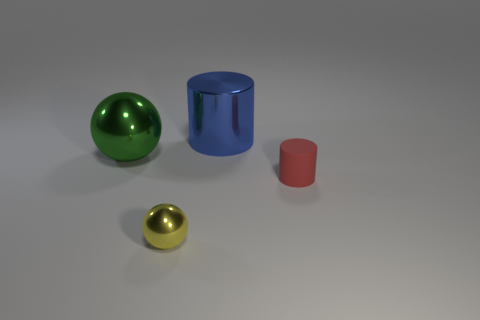There is a blue cylinder that is the same material as the yellow object; what is its size?
Offer a very short reply. Large. Is the size of the matte object the same as the yellow sphere to the left of the blue cylinder?
Provide a short and direct response. Yes. There is a metal thing that is behind the large green metal ball; what shape is it?
Offer a terse response. Cylinder. There is a tiny thing right of the shiny ball in front of the green object; are there any metallic things on the right side of it?
Your answer should be very brief. No. There is another object that is the same shape as the large blue thing; what material is it?
Your answer should be very brief. Rubber. Is there any other thing that has the same material as the red cylinder?
Provide a short and direct response. No. What number of cylinders are tiny blue metallic objects or tiny yellow metallic things?
Your answer should be compact. 0. Does the cylinder that is behind the green metal sphere have the same size as the ball that is to the left of the tiny metallic thing?
Keep it short and to the point. Yes. The small thing that is behind the yellow metallic object to the right of the green ball is made of what material?
Make the answer very short. Rubber. Is the number of red objects in front of the yellow thing less than the number of tiny matte cylinders?
Provide a succinct answer. Yes. 